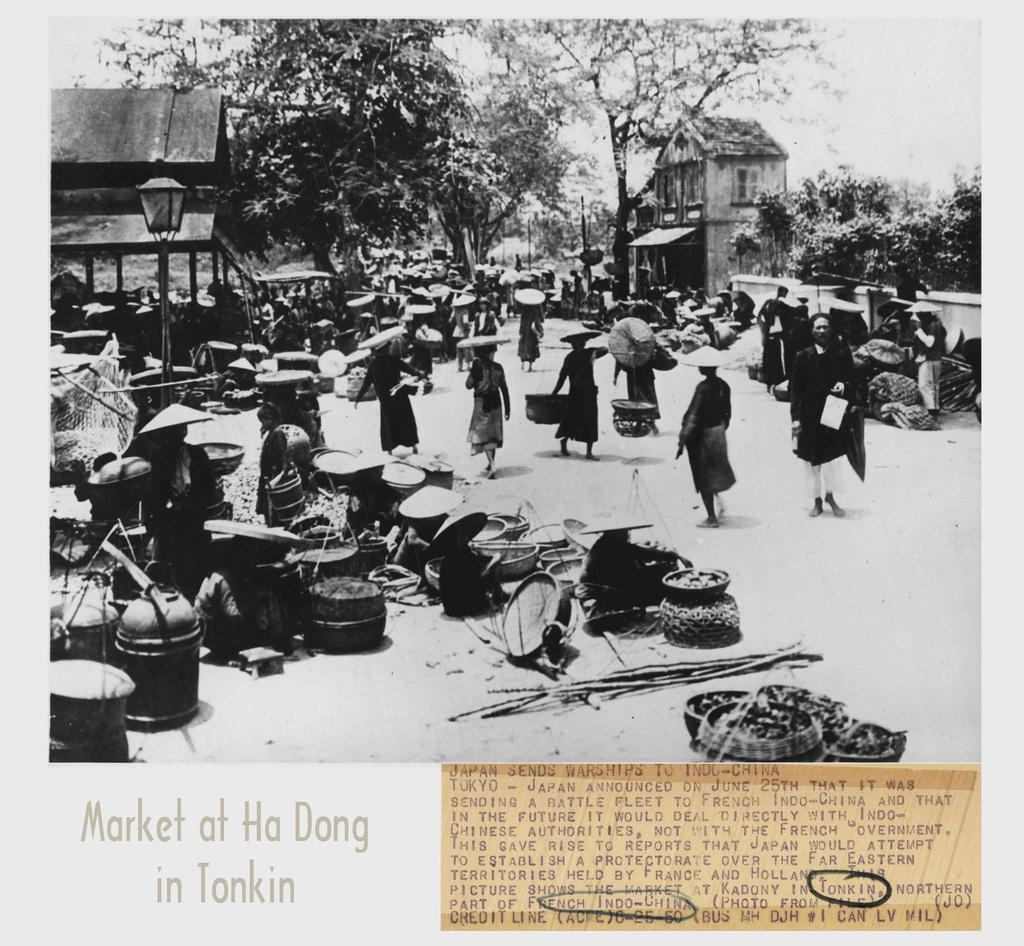<image>
Render a clear and concise summary of the photo. The Market at Ha Dong is pictured here. 